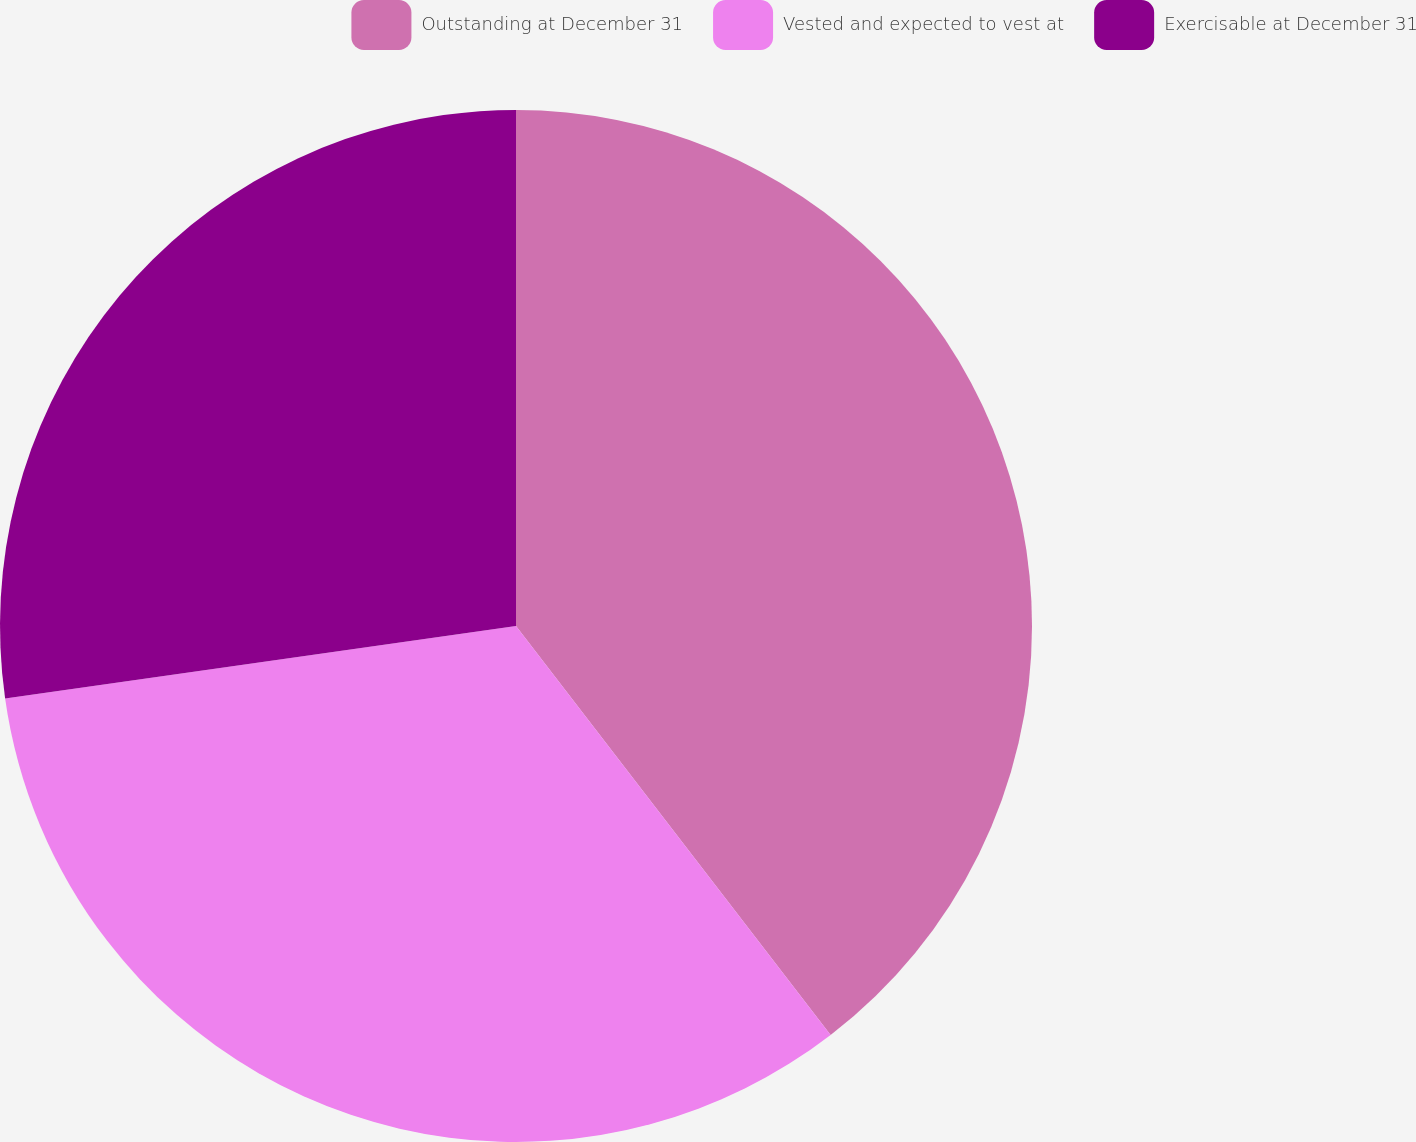<chart> <loc_0><loc_0><loc_500><loc_500><pie_chart><fcel>Outstanding at December 31<fcel>Vested and expected to vest at<fcel>Exercisable at December 31<nl><fcel>39.56%<fcel>33.19%<fcel>27.24%<nl></chart> 